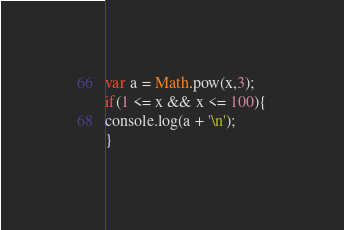Convert code to text. <code><loc_0><loc_0><loc_500><loc_500><_JavaScript_>var a = Math.pow(x,3);
if(1 <= x && x <= 100){
console.log(a + '\n');
}
</code> 